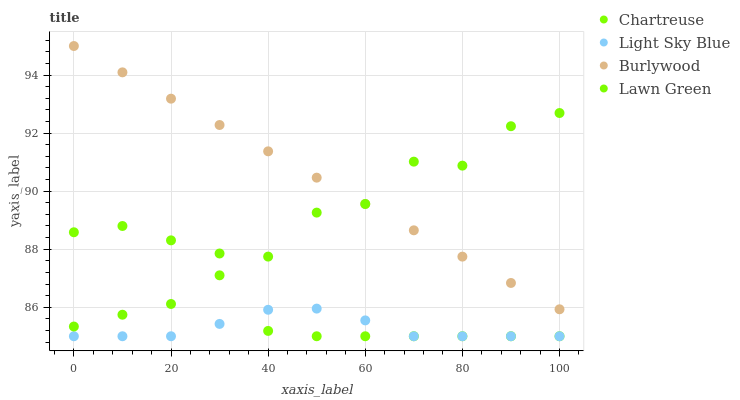Does Light Sky Blue have the minimum area under the curve?
Answer yes or no. Yes. Does Burlywood have the maximum area under the curve?
Answer yes or no. Yes. Does Lawn Green have the minimum area under the curve?
Answer yes or no. No. Does Lawn Green have the maximum area under the curve?
Answer yes or no. No. Is Burlywood the smoothest?
Answer yes or no. Yes. Is Lawn Green the roughest?
Answer yes or no. Yes. Is Chartreuse the smoothest?
Answer yes or no. No. Is Chartreuse the roughest?
Answer yes or no. No. Does Chartreuse have the lowest value?
Answer yes or no. Yes. Does Lawn Green have the lowest value?
Answer yes or no. No. Does Burlywood have the highest value?
Answer yes or no. Yes. Does Lawn Green have the highest value?
Answer yes or no. No. Is Light Sky Blue less than Lawn Green?
Answer yes or no. Yes. Is Lawn Green greater than Light Sky Blue?
Answer yes or no. Yes. Does Light Sky Blue intersect Chartreuse?
Answer yes or no. Yes. Is Light Sky Blue less than Chartreuse?
Answer yes or no. No. Is Light Sky Blue greater than Chartreuse?
Answer yes or no. No. Does Light Sky Blue intersect Lawn Green?
Answer yes or no. No. 